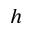Convert formula to latex. <formula><loc_0><loc_0><loc_500><loc_500>h</formula> 